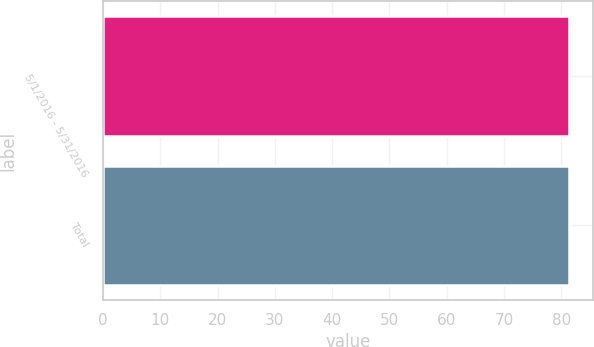Convert chart to OTSL. <chart><loc_0><loc_0><loc_500><loc_500><bar_chart><fcel>5/1/2016 - 5/31/2016<fcel>Total<nl><fcel>81.27<fcel>81.37<nl></chart> 